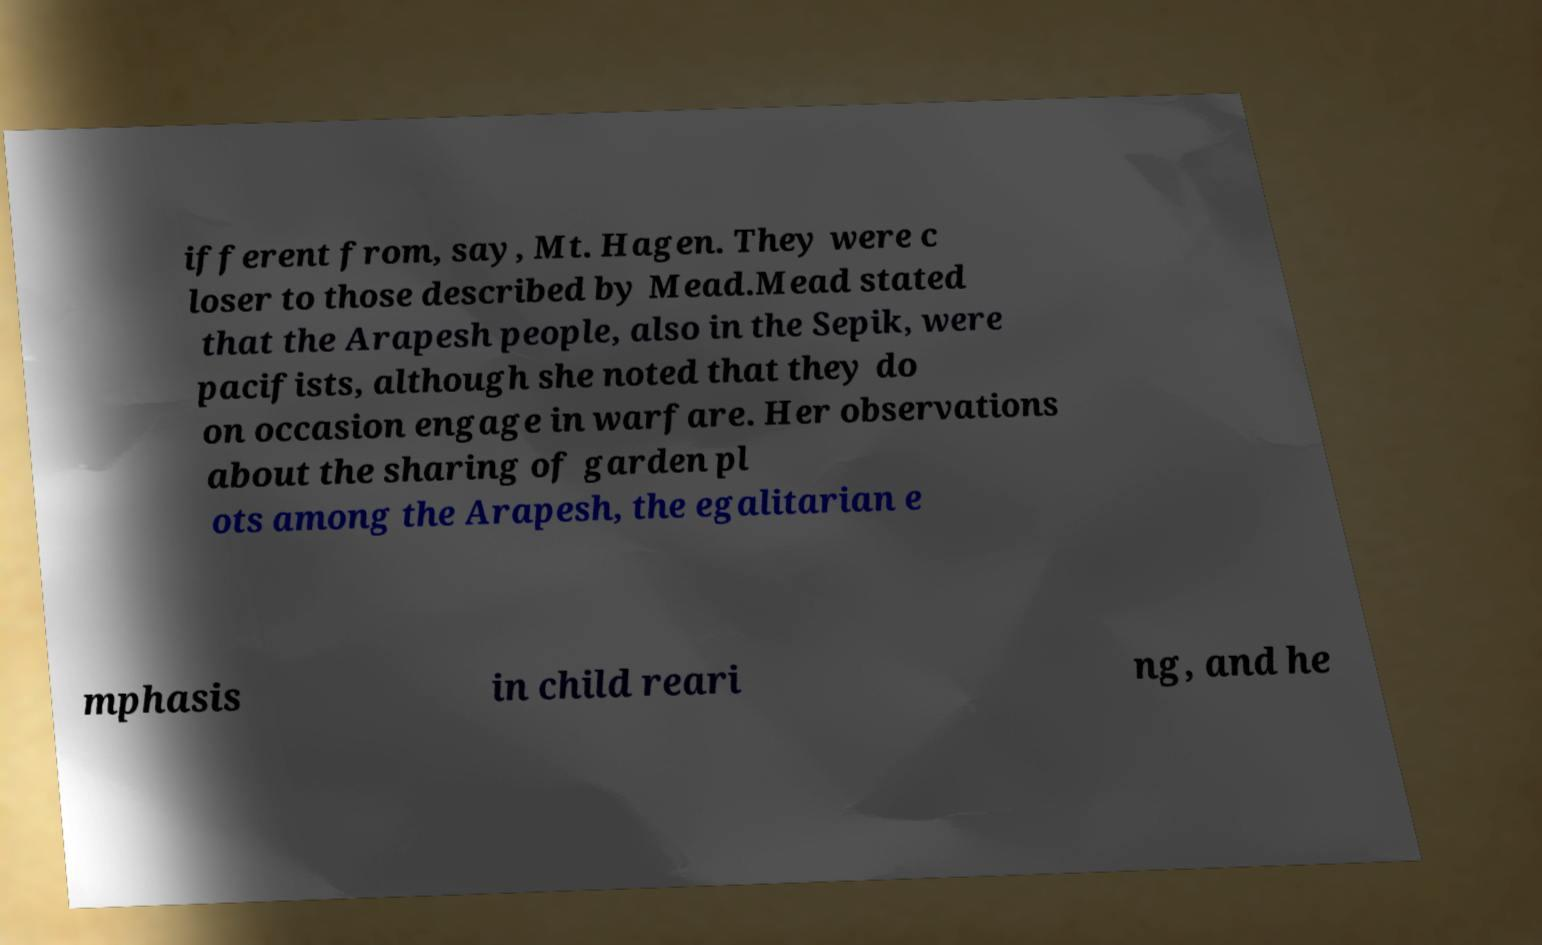Can you accurately transcribe the text from the provided image for me? ifferent from, say, Mt. Hagen. They were c loser to those described by Mead.Mead stated that the Arapesh people, also in the Sepik, were pacifists, although she noted that they do on occasion engage in warfare. Her observations about the sharing of garden pl ots among the Arapesh, the egalitarian e mphasis in child reari ng, and he 